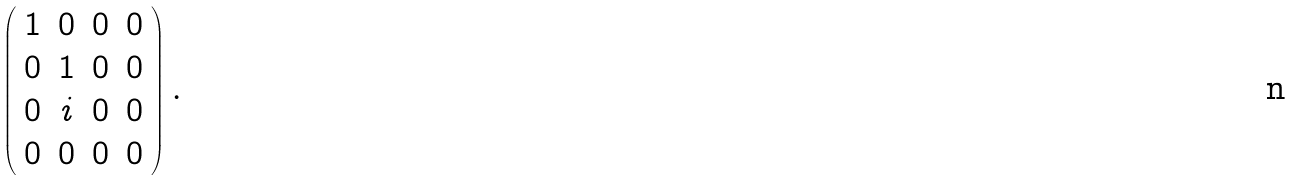<formula> <loc_0><loc_0><loc_500><loc_500>\left ( \begin{array} { c c c c } 1 & 0 & 0 & 0 \\ 0 & 1 & 0 & 0 \\ 0 & i & 0 & 0 \\ 0 & 0 & 0 & 0 \end{array} \right ) .</formula> 